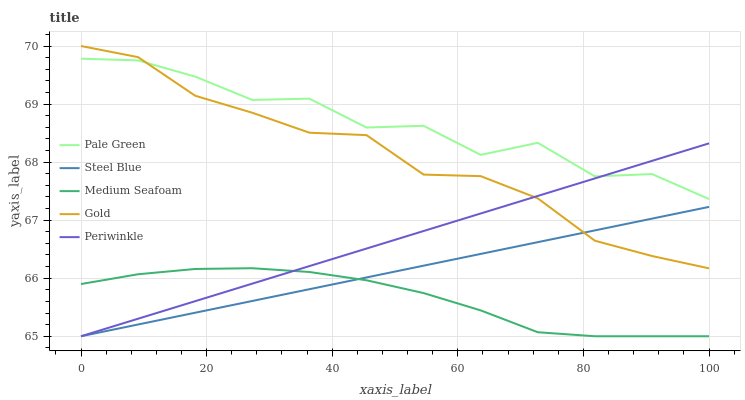Does Medium Seafoam have the minimum area under the curve?
Answer yes or no. Yes. Does Pale Green have the maximum area under the curve?
Answer yes or no. Yes. Does Periwinkle have the minimum area under the curve?
Answer yes or no. No. Does Periwinkle have the maximum area under the curve?
Answer yes or no. No. Is Steel Blue the smoothest?
Answer yes or no. Yes. Is Pale Green the roughest?
Answer yes or no. Yes. Is Periwinkle the smoothest?
Answer yes or no. No. Is Periwinkle the roughest?
Answer yes or no. No. Does Periwinkle have the lowest value?
Answer yes or no. Yes. Does Gold have the lowest value?
Answer yes or no. No. Does Gold have the highest value?
Answer yes or no. Yes. Does Periwinkle have the highest value?
Answer yes or no. No. Is Medium Seafoam less than Pale Green?
Answer yes or no. Yes. Is Pale Green greater than Medium Seafoam?
Answer yes or no. Yes. Does Periwinkle intersect Steel Blue?
Answer yes or no. Yes. Is Periwinkle less than Steel Blue?
Answer yes or no. No. Is Periwinkle greater than Steel Blue?
Answer yes or no. No. Does Medium Seafoam intersect Pale Green?
Answer yes or no. No. 